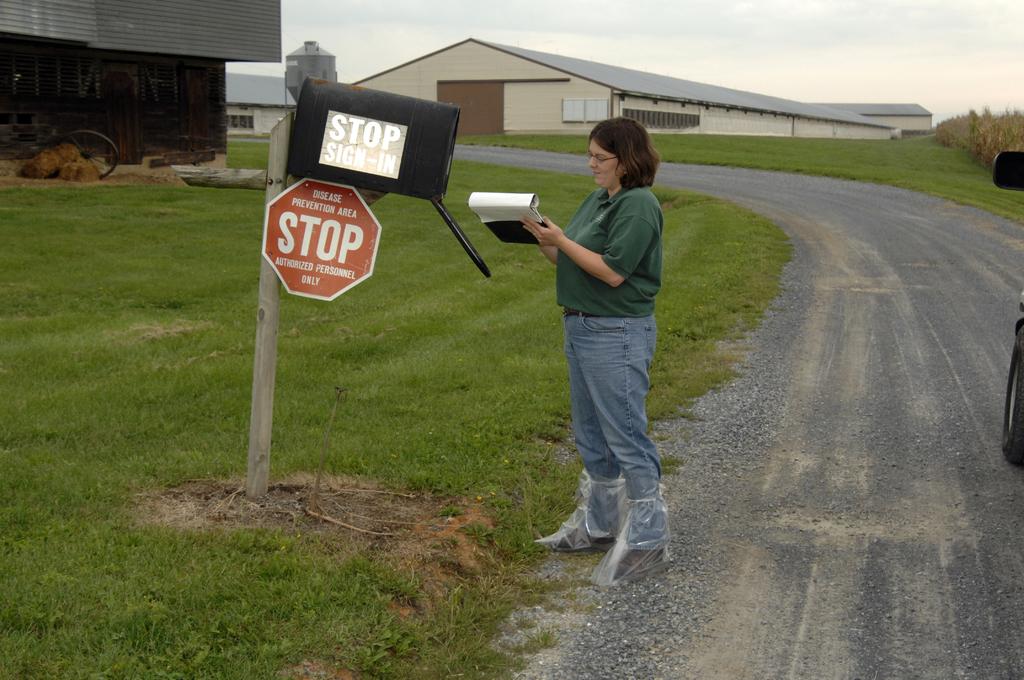What does the red sign say?
Your answer should be compact. Stop. 